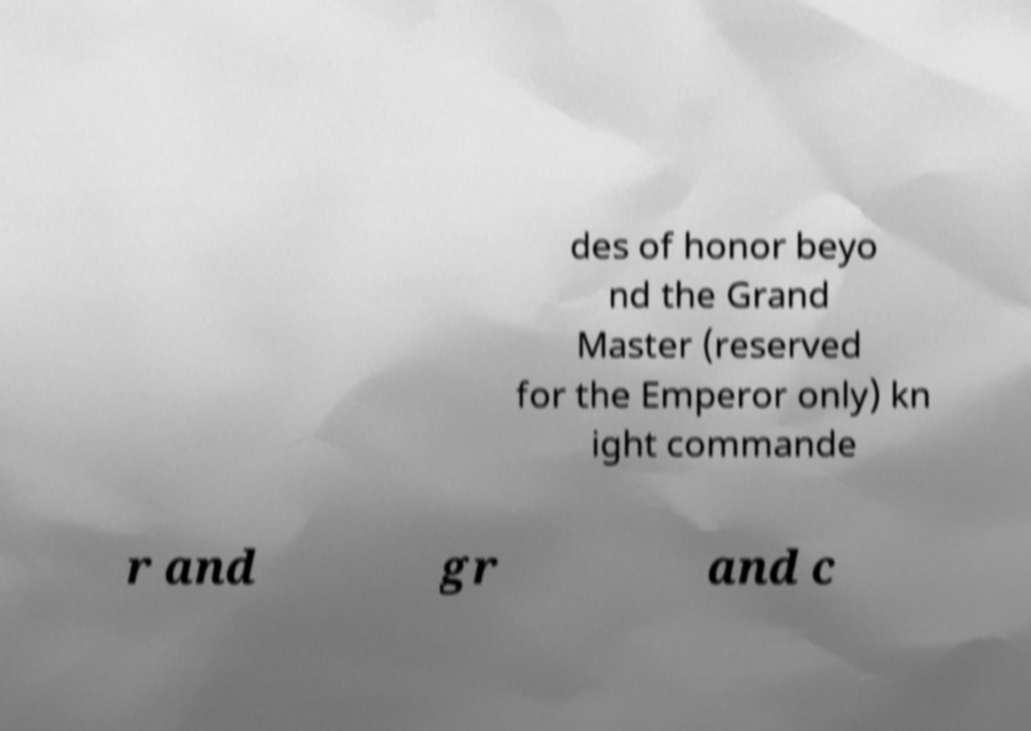Can you accurately transcribe the text from the provided image for me? des of honor beyo nd the Grand Master (reserved for the Emperor only) kn ight commande r and gr and c 